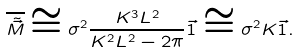<formula> <loc_0><loc_0><loc_500><loc_500>\overline { \tilde { \vec { M } } } \cong \sigma ^ { 2 } \frac { K ^ { 3 } L ^ { 2 } } { K ^ { 2 } L ^ { 2 } - 2 \pi } \vec { 1 } \cong \sigma ^ { 2 } K \vec { 1 } .</formula> 